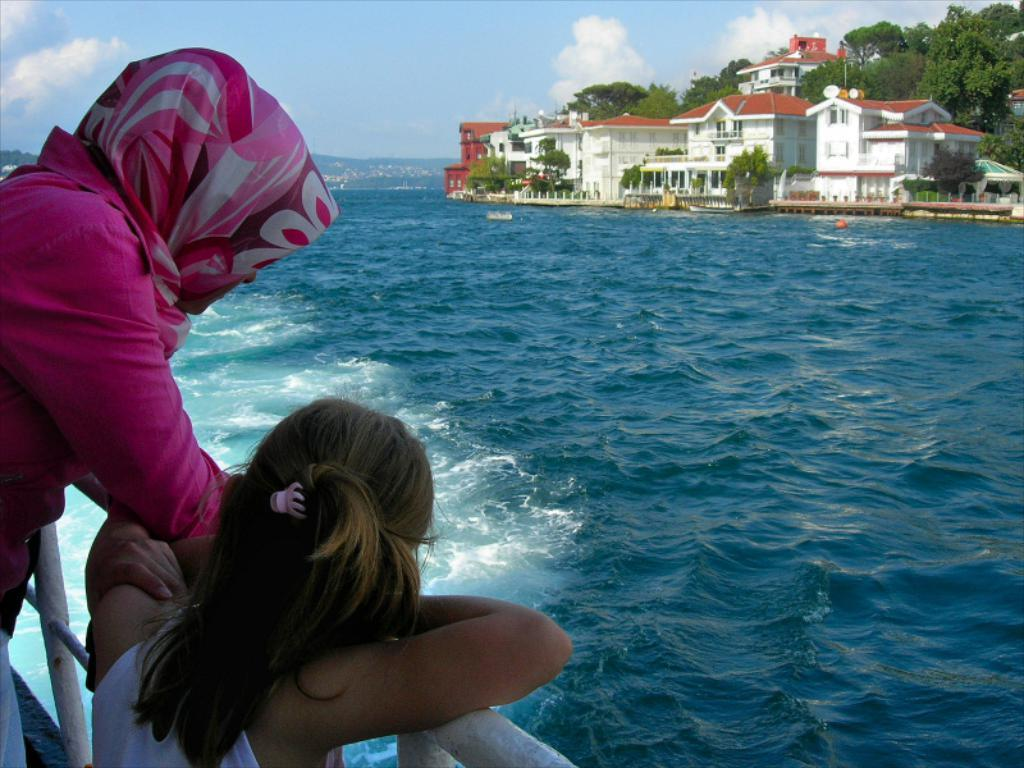What are the main subjects in the center of the image? There are persons standing in the center of the image. What can be seen on the right side of the image? There are buildings and trees on the right side of the image. How would you describe the sky in the image? The sky is cloudy in the image. What is present in the center of the image besides the persons? There is water in the center of the image. What type of headgear is the carpenter wearing in the image? There is no carpenter present in the image, and therefore no headgear can be observed. 